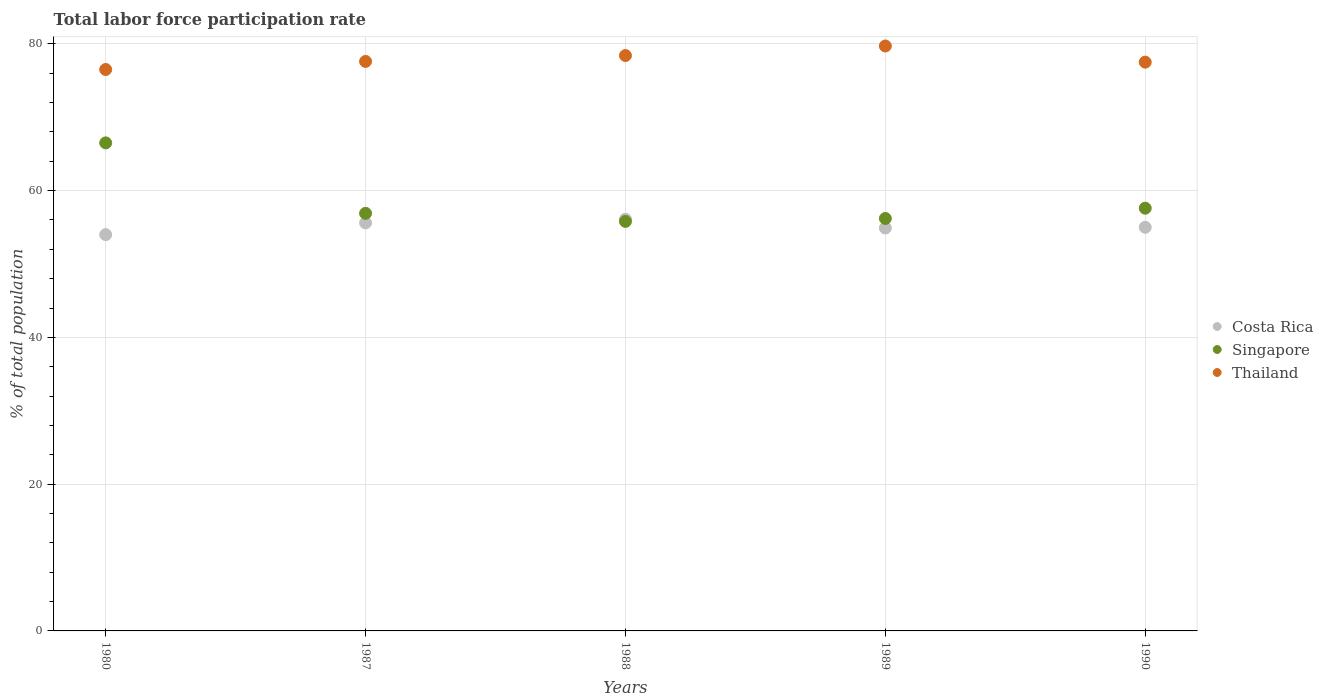Is the number of dotlines equal to the number of legend labels?
Your response must be concise. Yes. What is the total labor force participation rate in Singapore in 1990?
Keep it short and to the point. 57.6. Across all years, what is the maximum total labor force participation rate in Costa Rica?
Offer a very short reply. 56.1. Across all years, what is the minimum total labor force participation rate in Thailand?
Offer a terse response. 76.5. In which year was the total labor force participation rate in Thailand maximum?
Make the answer very short. 1989. In which year was the total labor force participation rate in Thailand minimum?
Your answer should be compact. 1980. What is the total total labor force participation rate in Costa Rica in the graph?
Your response must be concise. 275.6. What is the difference between the total labor force participation rate in Thailand in 1989 and the total labor force participation rate in Singapore in 1980?
Provide a succinct answer. 13.2. What is the average total labor force participation rate in Costa Rica per year?
Give a very brief answer. 55.12. In the year 1988, what is the difference between the total labor force participation rate in Costa Rica and total labor force participation rate in Thailand?
Your answer should be very brief. -22.3. What is the ratio of the total labor force participation rate in Thailand in 1987 to that in 1990?
Offer a very short reply. 1. What is the difference between the highest and the second highest total labor force participation rate in Singapore?
Make the answer very short. 8.9. What is the difference between the highest and the lowest total labor force participation rate in Thailand?
Ensure brevity in your answer.  3.2. In how many years, is the total labor force participation rate in Costa Rica greater than the average total labor force participation rate in Costa Rica taken over all years?
Provide a short and direct response. 2. Does the total labor force participation rate in Costa Rica monotonically increase over the years?
Keep it short and to the point. No. Is the total labor force participation rate in Singapore strictly less than the total labor force participation rate in Costa Rica over the years?
Keep it short and to the point. No. How many years are there in the graph?
Provide a succinct answer. 5. What is the difference between two consecutive major ticks on the Y-axis?
Your response must be concise. 20. Does the graph contain grids?
Provide a short and direct response. Yes. Where does the legend appear in the graph?
Your response must be concise. Center right. How many legend labels are there?
Provide a succinct answer. 3. What is the title of the graph?
Give a very brief answer. Total labor force participation rate. Does "Kenya" appear as one of the legend labels in the graph?
Ensure brevity in your answer.  No. What is the label or title of the Y-axis?
Your response must be concise. % of total population. What is the % of total population in Costa Rica in 1980?
Provide a succinct answer. 54. What is the % of total population of Singapore in 1980?
Your response must be concise. 66.5. What is the % of total population in Thailand in 1980?
Ensure brevity in your answer.  76.5. What is the % of total population of Costa Rica in 1987?
Your response must be concise. 55.6. What is the % of total population of Singapore in 1987?
Ensure brevity in your answer.  56.9. What is the % of total population in Thailand in 1987?
Ensure brevity in your answer.  77.6. What is the % of total population of Costa Rica in 1988?
Provide a succinct answer. 56.1. What is the % of total population in Singapore in 1988?
Offer a terse response. 55.8. What is the % of total population in Thailand in 1988?
Offer a very short reply. 78.4. What is the % of total population of Costa Rica in 1989?
Your answer should be very brief. 54.9. What is the % of total population of Singapore in 1989?
Give a very brief answer. 56.2. What is the % of total population of Thailand in 1989?
Your response must be concise. 79.7. What is the % of total population in Costa Rica in 1990?
Keep it short and to the point. 55. What is the % of total population of Singapore in 1990?
Provide a short and direct response. 57.6. What is the % of total population in Thailand in 1990?
Give a very brief answer. 77.5. Across all years, what is the maximum % of total population of Costa Rica?
Your answer should be very brief. 56.1. Across all years, what is the maximum % of total population of Singapore?
Keep it short and to the point. 66.5. Across all years, what is the maximum % of total population in Thailand?
Provide a short and direct response. 79.7. Across all years, what is the minimum % of total population in Singapore?
Ensure brevity in your answer.  55.8. Across all years, what is the minimum % of total population of Thailand?
Offer a terse response. 76.5. What is the total % of total population of Costa Rica in the graph?
Offer a very short reply. 275.6. What is the total % of total population of Singapore in the graph?
Offer a terse response. 293. What is the total % of total population of Thailand in the graph?
Provide a short and direct response. 389.7. What is the difference between the % of total population in Singapore in 1980 and that in 1987?
Your response must be concise. 9.6. What is the difference between the % of total population in Thailand in 1980 and that in 1988?
Ensure brevity in your answer.  -1.9. What is the difference between the % of total population of Costa Rica in 1980 and that in 1990?
Ensure brevity in your answer.  -1. What is the difference between the % of total population in Singapore in 1980 and that in 1990?
Provide a short and direct response. 8.9. What is the difference between the % of total population of Costa Rica in 1987 and that in 1988?
Your response must be concise. -0.5. What is the difference between the % of total population of Costa Rica in 1987 and that in 1989?
Your answer should be very brief. 0.7. What is the difference between the % of total population in Singapore in 1987 and that in 1989?
Make the answer very short. 0.7. What is the difference between the % of total population of Thailand in 1987 and that in 1989?
Your answer should be compact. -2.1. What is the difference between the % of total population in Singapore in 1987 and that in 1990?
Provide a succinct answer. -0.7. What is the difference between the % of total population in Thailand in 1987 and that in 1990?
Your answer should be very brief. 0.1. What is the difference between the % of total population in Singapore in 1988 and that in 1989?
Keep it short and to the point. -0.4. What is the difference between the % of total population of Singapore in 1988 and that in 1990?
Give a very brief answer. -1.8. What is the difference between the % of total population in Thailand in 1989 and that in 1990?
Ensure brevity in your answer.  2.2. What is the difference between the % of total population in Costa Rica in 1980 and the % of total population in Thailand in 1987?
Offer a terse response. -23.6. What is the difference between the % of total population of Singapore in 1980 and the % of total population of Thailand in 1987?
Your answer should be very brief. -11.1. What is the difference between the % of total population in Costa Rica in 1980 and the % of total population in Thailand in 1988?
Ensure brevity in your answer.  -24.4. What is the difference between the % of total population in Singapore in 1980 and the % of total population in Thailand in 1988?
Give a very brief answer. -11.9. What is the difference between the % of total population of Costa Rica in 1980 and the % of total population of Thailand in 1989?
Give a very brief answer. -25.7. What is the difference between the % of total population in Costa Rica in 1980 and the % of total population in Singapore in 1990?
Ensure brevity in your answer.  -3.6. What is the difference between the % of total population of Costa Rica in 1980 and the % of total population of Thailand in 1990?
Give a very brief answer. -23.5. What is the difference between the % of total population of Costa Rica in 1987 and the % of total population of Singapore in 1988?
Offer a very short reply. -0.2. What is the difference between the % of total population of Costa Rica in 1987 and the % of total population of Thailand in 1988?
Make the answer very short. -22.8. What is the difference between the % of total population in Singapore in 1987 and the % of total population in Thailand in 1988?
Give a very brief answer. -21.5. What is the difference between the % of total population of Costa Rica in 1987 and the % of total population of Singapore in 1989?
Your answer should be compact. -0.6. What is the difference between the % of total population of Costa Rica in 1987 and the % of total population of Thailand in 1989?
Your answer should be compact. -24.1. What is the difference between the % of total population of Singapore in 1987 and the % of total population of Thailand in 1989?
Your answer should be very brief. -22.8. What is the difference between the % of total population in Costa Rica in 1987 and the % of total population in Thailand in 1990?
Your answer should be very brief. -21.9. What is the difference between the % of total population in Singapore in 1987 and the % of total population in Thailand in 1990?
Offer a terse response. -20.6. What is the difference between the % of total population of Costa Rica in 1988 and the % of total population of Singapore in 1989?
Offer a terse response. -0.1. What is the difference between the % of total population of Costa Rica in 1988 and the % of total population of Thailand in 1989?
Your answer should be very brief. -23.6. What is the difference between the % of total population of Singapore in 1988 and the % of total population of Thailand in 1989?
Offer a very short reply. -23.9. What is the difference between the % of total population in Costa Rica in 1988 and the % of total population in Thailand in 1990?
Ensure brevity in your answer.  -21.4. What is the difference between the % of total population in Singapore in 1988 and the % of total population in Thailand in 1990?
Your response must be concise. -21.7. What is the difference between the % of total population in Costa Rica in 1989 and the % of total population in Thailand in 1990?
Offer a very short reply. -22.6. What is the difference between the % of total population in Singapore in 1989 and the % of total population in Thailand in 1990?
Provide a short and direct response. -21.3. What is the average % of total population in Costa Rica per year?
Make the answer very short. 55.12. What is the average % of total population of Singapore per year?
Give a very brief answer. 58.6. What is the average % of total population in Thailand per year?
Keep it short and to the point. 77.94. In the year 1980, what is the difference between the % of total population of Costa Rica and % of total population of Thailand?
Your answer should be compact. -22.5. In the year 1987, what is the difference between the % of total population in Costa Rica and % of total population in Singapore?
Give a very brief answer. -1.3. In the year 1987, what is the difference between the % of total population in Costa Rica and % of total population in Thailand?
Make the answer very short. -22. In the year 1987, what is the difference between the % of total population of Singapore and % of total population of Thailand?
Keep it short and to the point. -20.7. In the year 1988, what is the difference between the % of total population in Costa Rica and % of total population in Singapore?
Your response must be concise. 0.3. In the year 1988, what is the difference between the % of total population of Costa Rica and % of total population of Thailand?
Keep it short and to the point. -22.3. In the year 1988, what is the difference between the % of total population in Singapore and % of total population in Thailand?
Keep it short and to the point. -22.6. In the year 1989, what is the difference between the % of total population of Costa Rica and % of total population of Singapore?
Your answer should be compact. -1.3. In the year 1989, what is the difference between the % of total population of Costa Rica and % of total population of Thailand?
Your answer should be compact. -24.8. In the year 1989, what is the difference between the % of total population in Singapore and % of total population in Thailand?
Provide a short and direct response. -23.5. In the year 1990, what is the difference between the % of total population of Costa Rica and % of total population of Thailand?
Ensure brevity in your answer.  -22.5. In the year 1990, what is the difference between the % of total population in Singapore and % of total population in Thailand?
Make the answer very short. -19.9. What is the ratio of the % of total population of Costa Rica in 1980 to that in 1987?
Provide a succinct answer. 0.97. What is the ratio of the % of total population of Singapore in 1980 to that in 1987?
Offer a terse response. 1.17. What is the ratio of the % of total population in Thailand in 1980 to that in 1987?
Make the answer very short. 0.99. What is the ratio of the % of total population of Costa Rica in 1980 to that in 1988?
Your answer should be very brief. 0.96. What is the ratio of the % of total population in Singapore in 1980 to that in 1988?
Make the answer very short. 1.19. What is the ratio of the % of total population in Thailand in 1980 to that in 1988?
Your answer should be very brief. 0.98. What is the ratio of the % of total population of Costa Rica in 1980 to that in 1989?
Your response must be concise. 0.98. What is the ratio of the % of total population in Singapore in 1980 to that in 1989?
Offer a terse response. 1.18. What is the ratio of the % of total population in Thailand in 1980 to that in 1989?
Your answer should be compact. 0.96. What is the ratio of the % of total population of Costa Rica in 1980 to that in 1990?
Give a very brief answer. 0.98. What is the ratio of the % of total population of Singapore in 1980 to that in 1990?
Provide a short and direct response. 1.15. What is the ratio of the % of total population in Thailand in 1980 to that in 1990?
Ensure brevity in your answer.  0.99. What is the ratio of the % of total population of Costa Rica in 1987 to that in 1988?
Offer a very short reply. 0.99. What is the ratio of the % of total population of Singapore in 1987 to that in 1988?
Your answer should be compact. 1.02. What is the ratio of the % of total population of Thailand in 1987 to that in 1988?
Make the answer very short. 0.99. What is the ratio of the % of total population in Costa Rica in 1987 to that in 1989?
Your answer should be compact. 1.01. What is the ratio of the % of total population of Singapore in 1987 to that in 1989?
Make the answer very short. 1.01. What is the ratio of the % of total population in Thailand in 1987 to that in 1989?
Make the answer very short. 0.97. What is the ratio of the % of total population of Costa Rica in 1987 to that in 1990?
Provide a succinct answer. 1.01. What is the ratio of the % of total population in Singapore in 1987 to that in 1990?
Make the answer very short. 0.99. What is the ratio of the % of total population in Thailand in 1987 to that in 1990?
Provide a succinct answer. 1. What is the ratio of the % of total population of Costa Rica in 1988 to that in 1989?
Ensure brevity in your answer.  1.02. What is the ratio of the % of total population in Singapore in 1988 to that in 1989?
Ensure brevity in your answer.  0.99. What is the ratio of the % of total population of Thailand in 1988 to that in 1989?
Provide a short and direct response. 0.98. What is the ratio of the % of total population in Costa Rica in 1988 to that in 1990?
Your answer should be very brief. 1.02. What is the ratio of the % of total population in Singapore in 1988 to that in 1990?
Your answer should be compact. 0.97. What is the ratio of the % of total population of Thailand in 1988 to that in 1990?
Give a very brief answer. 1.01. What is the ratio of the % of total population of Singapore in 1989 to that in 1990?
Ensure brevity in your answer.  0.98. What is the ratio of the % of total population in Thailand in 1989 to that in 1990?
Keep it short and to the point. 1.03. What is the difference between the highest and the second highest % of total population of Thailand?
Give a very brief answer. 1.3. What is the difference between the highest and the lowest % of total population in Singapore?
Ensure brevity in your answer.  10.7. 